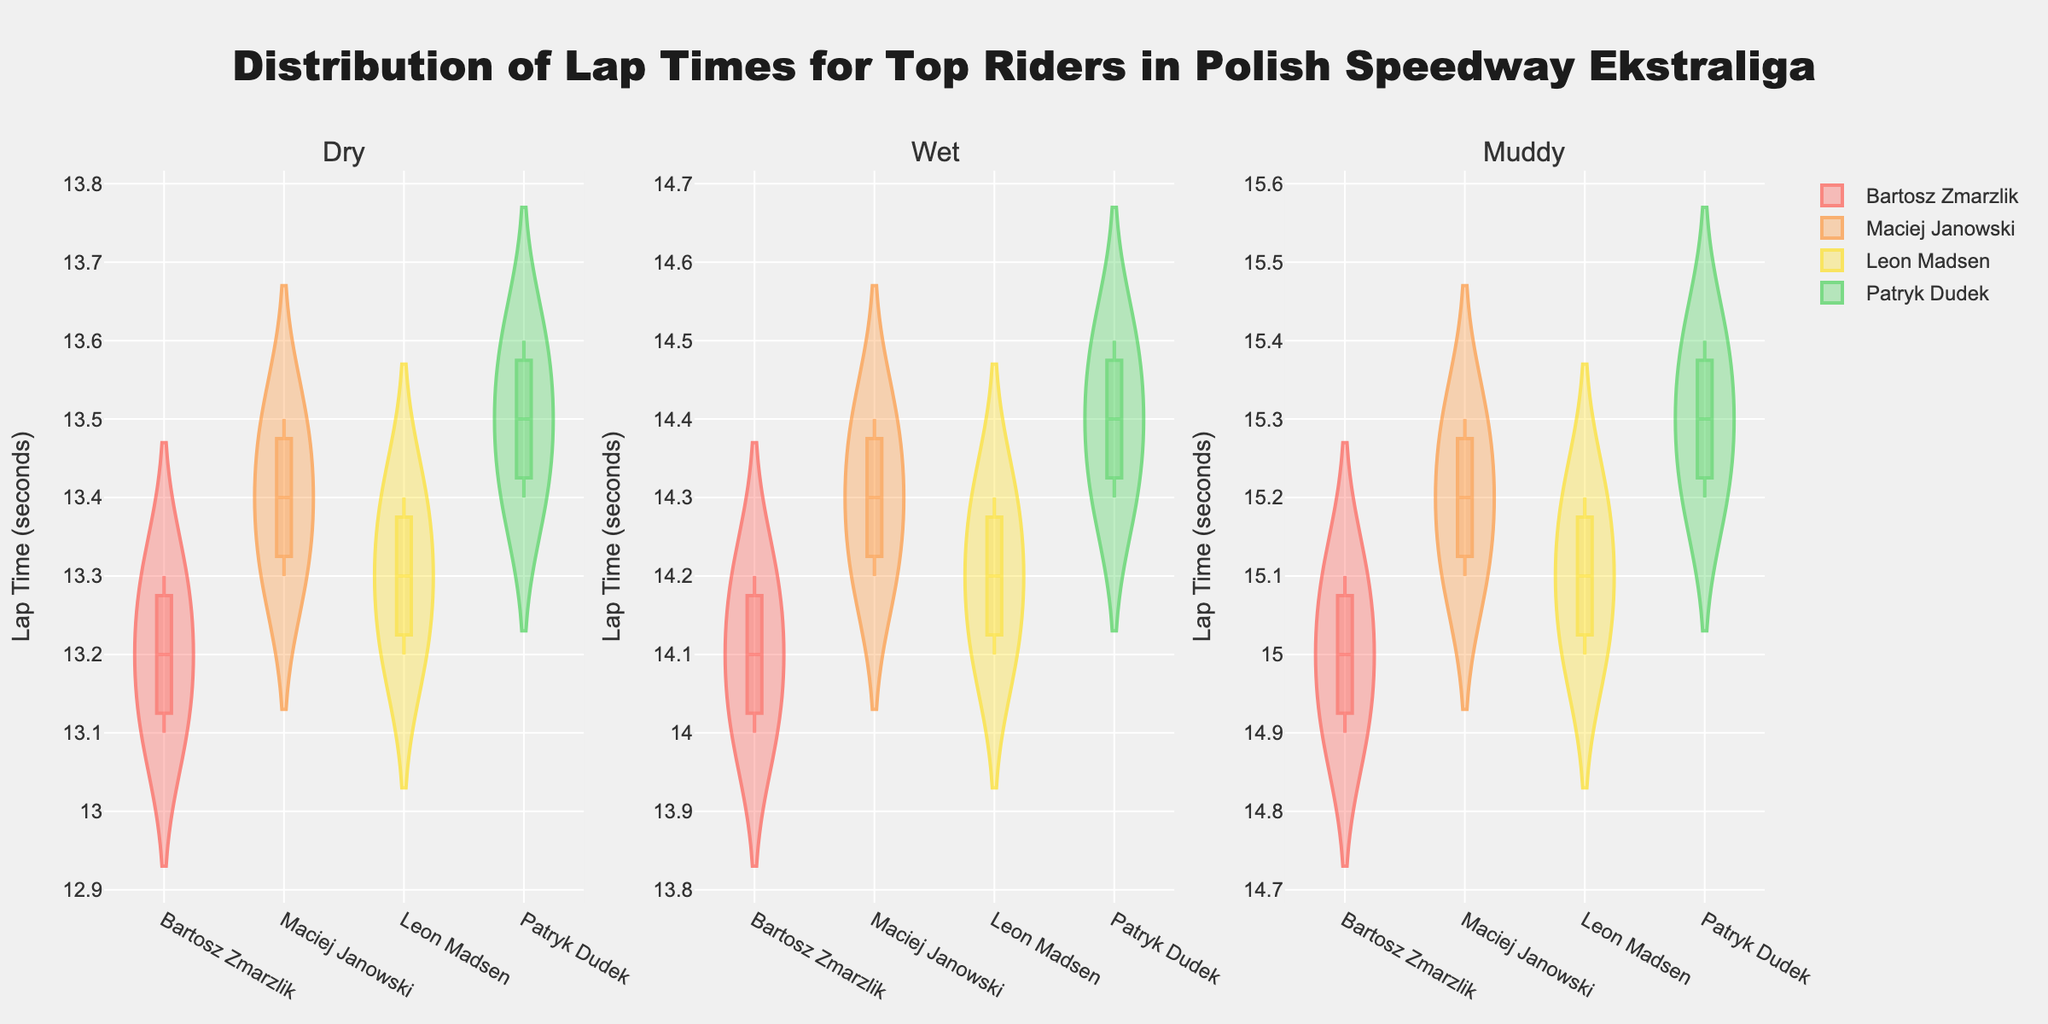What's the title of the plot? The title of the plot is clearly displayed at the top of the figure.
Answer: Distribution of Lap Times for Top Riders in Polish Speedway Ekstraliga Which subplot represents Wet track conditions? By examining the subplot titles at the top of each subplot, you can identify the subplot representing the Wet track conditions.
Answer: The middle subplot Which rider has the lowest median lap time on Dry tracks? Observe the vertical position of the median line for each rider in the Dry subplot. The rider with the lowest median line has the lowest median lap time.
Answer: Bartosz Zmarzlik How do the median lap times compare between Dry and Wet track conditions for Bartosz Zmarzlik? Compare the median lines for Bartosz Zmarzlik in the Dry and Wet subplots. The median line is represented by the darker horizontal line within each violin plot.
Answer: Higher in Wet conditions What is the range of lap times for Leon Madsen on Muddy tracks? In the Muddy subplot, look at the extent of Leon Madsen's violin plot, from the lowest to the highest value covered by the plot.
Answer: From 15.0 to 15.2 seconds Which rider shows the largest increase in median lap time when moving from Dry to Muddy track conditions? Compare the median lines from the Dry and Muddy subplots for each rider and identify the one with the greatest upward shift.
Answer: Patryk Dudek Is there a rider whose lap time distribution overlaps significantly between Dry and Wet track conditions? Check if any rider's violin plots in the Dry subplot overlap significantly with their violin plots in the Wet subplot.
Answer: Yes, Maciej Janowski Which track condition generally has the slowest lap times? By comparing the overall range and median lines of the violin plots across all subplots, you can determine which track condition has the highest lap times.
Answer: Muddy Between Wet and Muddy conditions, which generates more variation in lap times for Patryk Dudek? Observe the spread of Patryk Dudek's violin plots in the Wet and Muddy subplots, the plot with a wider spread indicates higher variation.
Answer: Muddy 